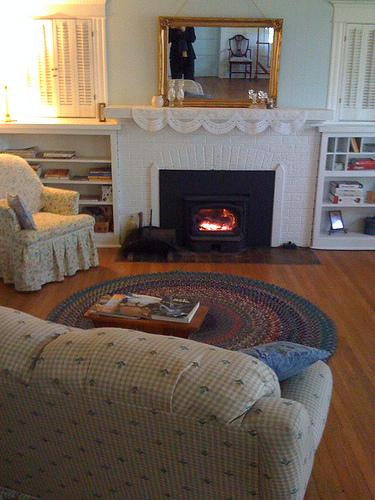Question: what is tan?
Choices:
A. The man.
B. The woman.
C. The dog.
D. Couch.
Answer with the letter. Answer: D Question: who took the picture?
Choices:
A. Woman.
B. A man.
C. Papparazzi.
D. News person.
Answer with the letter. Answer: A Question: why is there a fire?
Choices:
A. Burning yard waste.
B. Ambiance.
C. It is cold.
D. To roast marshmelloes.
Answer with the letter. Answer: C Question: where is this room?
Choices:
A. The bedroom.
B. The bathroom.
C. Living room.
D. The guest room.
Answer with the letter. Answer: C Question: what is white?
Choices:
A. The tile.
B. The floor.
C. The people.
D. Fireplace.
Answer with the letter. Answer: D 